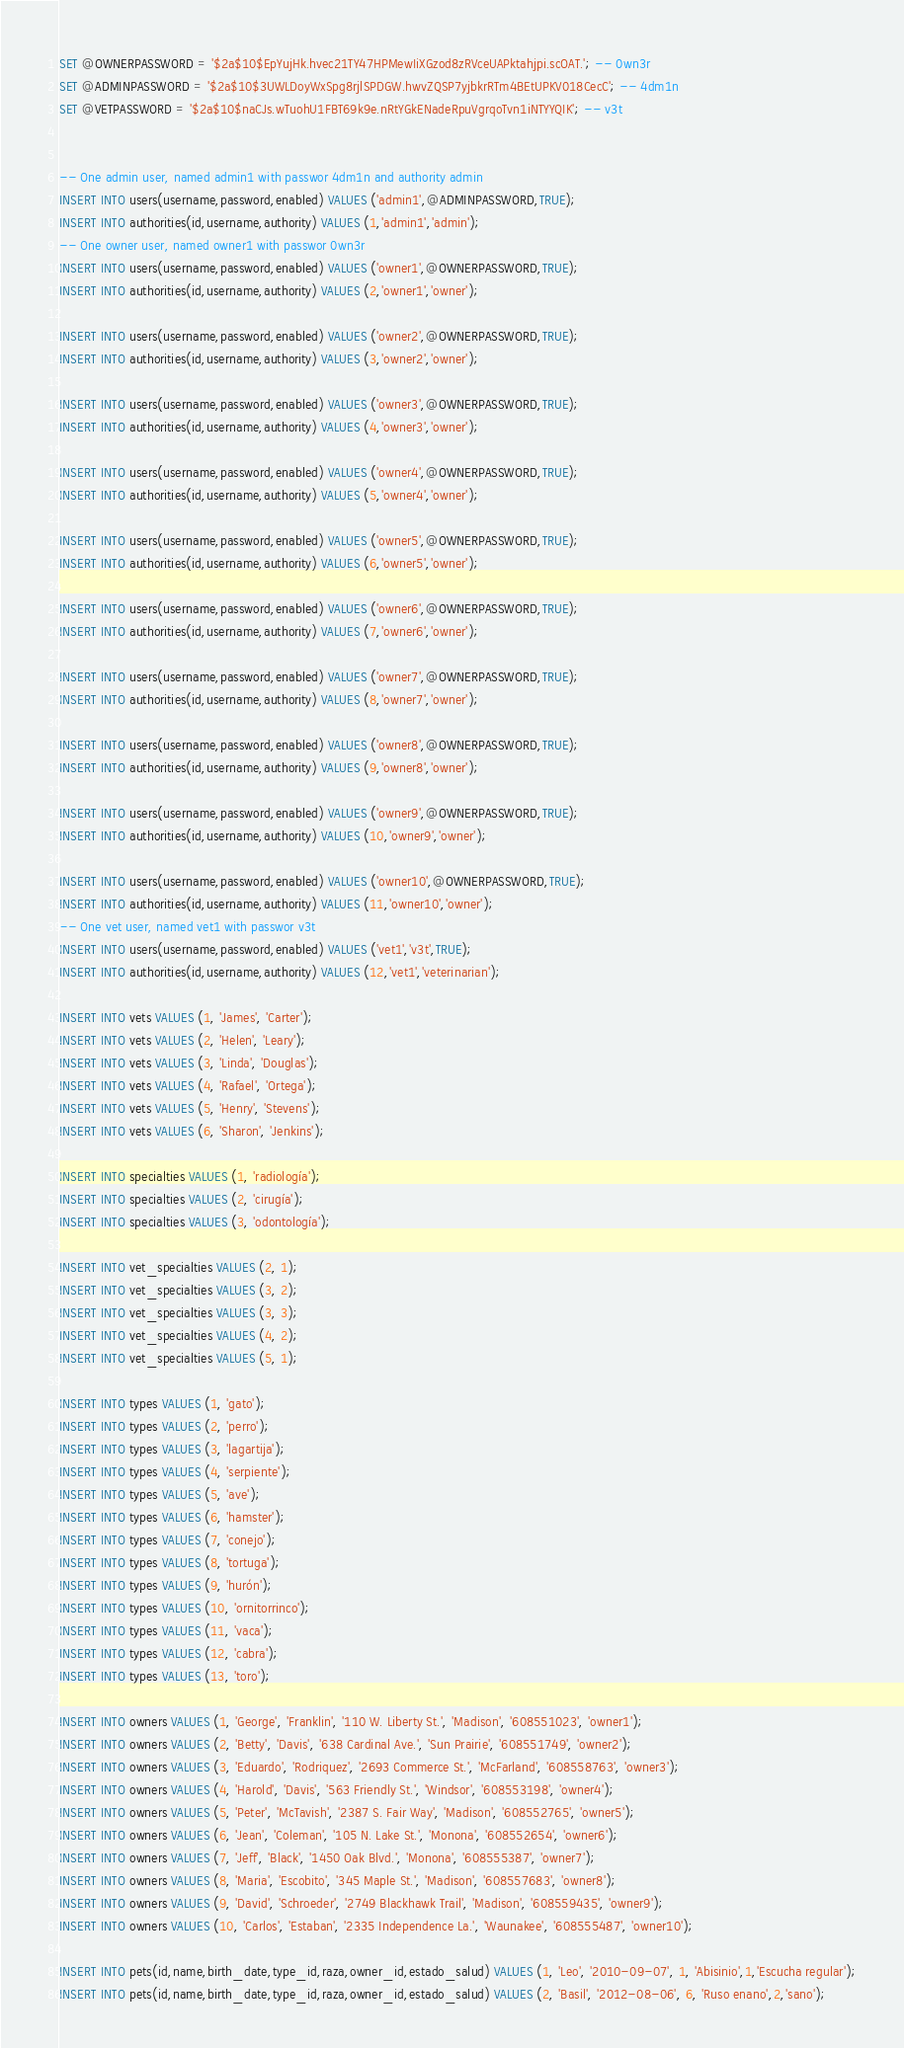Convert code to text. <code><loc_0><loc_0><loc_500><loc_500><_SQL_>SET @OWNERPASSWORD = '$2a$10$EpYujHk.hvec21TY47HPMewIiXGzod8zRVceUAPktahjpi.scOAT.'; -- 0wn3r
SET @ADMINPASSWORD = '$2a$10$3UWLDoyWxSpg8rjlSPDGW.hwvZQSP7yjbkrRTm4BEtUPKV018CecC'; -- 4dm1n
SET @VETPASSWORD = '$2a$10$naCJs.wTuohU1FBT69k9e.nRtYGkENadeRpuVgrqoTvn1iNTYYQIK'; -- v3t


-- One admin user, named admin1 with passwor 4dm1n and authority admin
INSERT INTO users(username,password,enabled) VALUES ('admin1',@ADMINPASSWORD,TRUE);
INSERT INTO authorities(id,username,authority) VALUES (1,'admin1','admin');
-- One owner user, named owner1 with passwor 0wn3r
INSERT INTO users(username,password,enabled) VALUES ('owner1',@OWNERPASSWORD,TRUE);
INSERT INTO authorities(id,username,authority) VALUES (2,'owner1','owner');

INSERT INTO users(username,password,enabled) VALUES ('owner2',@OWNERPASSWORD,TRUE);
INSERT INTO authorities(id,username,authority) VALUES (3,'owner2','owner');

INSERT INTO users(username,password,enabled) VALUES ('owner3',@OWNERPASSWORD,TRUE);
INSERT INTO authorities(id,username,authority) VALUES (4,'owner3','owner');

INSERT INTO users(username,password,enabled) VALUES ('owner4',@OWNERPASSWORD,TRUE);
INSERT INTO authorities(id,username,authority) VALUES (5,'owner4','owner');

INSERT INTO users(username,password,enabled) VALUES ('owner5',@OWNERPASSWORD,TRUE);
INSERT INTO authorities(id,username,authority) VALUES (6,'owner5','owner');

INSERT INTO users(username,password,enabled) VALUES ('owner6',@OWNERPASSWORD,TRUE);
INSERT INTO authorities(id,username,authority) VALUES (7,'owner6','owner');

INSERT INTO users(username,password,enabled) VALUES ('owner7',@OWNERPASSWORD,TRUE);
INSERT INTO authorities(id,username,authority) VALUES (8,'owner7','owner');

INSERT INTO users(username,password,enabled) VALUES ('owner8',@OWNERPASSWORD,TRUE);
INSERT INTO authorities(id,username,authority) VALUES (9,'owner8','owner');

INSERT INTO users(username,password,enabled) VALUES ('owner9',@OWNERPASSWORD,TRUE);
INSERT INTO authorities(id,username,authority) VALUES (10,'owner9','owner');

INSERT INTO users(username,password,enabled) VALUES ('owner10',@OWNERPASSWORD,TRUE);
INSERT INTO authorities(id,username,authority) VALUES (11,'owner10','owner');
-- One vet user, named vet1 with passwor v3t
INSERT INTO users(username,password,enabled) VALUES ('vet1','v3t',TRUE);
INSERT INTO authorities(id,username,authority) VALUES (12,'vet1','veterinarian');

INSERT INTO vets VALUES (1, 'James', 'Carter');
INSERT INTO vets VALUES (2, 'Helen', 'Leary');
INSERT INTO vets VALUES (3, 'Linda', 'Douglas');
INSERT INTO vets VALUES (4, 'Rafael', 'Ortega');
INSERT INTO vets VALUES (5, 'Henry', 'Stevens');
INSERT INTO vets VALUES (6, 'Sharon', 'Jenkins');

INSERT INTO specialties VALUES (1, 'radiología');
INSERT INTO specialties VALUES (2, 'cirugía');
INSERT INTO specialties VALUES (3, 'odontología');

INSERT INTO vet_specialties VALUES (2, 1);
INSERT INTO vet_specialties VALUES (3, 2);
INSERT INTO vet_specialties VALUES (3, 3);
INSERT INTO vet_specialties VALUES (4, 2);
INSERT INTO vet_specialties VALUES (5, 1);

INSERT INTO types VALUES (1, 'gato');
INSERT INTO types VALUES (2, 'perro');
INSERT INTO types VALUES (3, 'lagartija');
INSERT INTO types VALUES (4, 'serpiente');
INSERT INTO types VALUES (5, 'ave');
INSERT INTO types VALUES (6, 'hamster');
INSERT INTO types VALUES (7, 'conejo');
INSERT INTO types VALUES (8, 'tortuga');
INSERT INTO types VALUES (9, 'hurón');
INSERT INTO types VALUES (10, 'ornitorrinco');
INSERT INTO types VALUES (11, 'vaca');
INSERT INTO types VALUES (12, 'cabra');
INSERT INTO types VALUES (13, 'toro');

INSERT INTO owners VALUES (1, 'George', 'Franklin', '110 W. Liberty St.', 'Madison', '608551023', 'owner1');
INSERT INTO owners VALUES (2, 'Betty', 'Davis', '638 Cardinal Ave.', 'Sun Prairie', '608551749', 'owner2');
INSERT INTO owners VALUES (3, 'Eduardo', 'Rodriquez', '2693 Commerce St.', 'McFarland', '608558763', 'owner3');
INSERT INTO owners VALUES (4, 'Harold', 'Davis', '563 Friendly St.', 'Windsor', '608553198', 'owner4');
INSERT INTO owners VALUES (5, 'Peter', 'McTavish', '2387 S. Fair Way', 'Madison', '608552765', 'owner5');
INSERT INTO owners VALUES (6, 'Jean', 'Coleman', '105 N. Lake St.', 'Monona', '608552654', 'owner6');
INSERT INTO owners VALUES (7, 'Jeff', 'Black', '1450 Oak Blvd.', 'Monona', '608555387', 'owner7');
INSERT INTO owners VALUES (8, 'Maria', 'Escobito', '345 Maple St.', 'Madison', '608557683', 'owner8');
INSERT INTO owners VALUES (9, 'David', 'Schroeder', '2749 Blackhawk Trail', 'Madison', '608559435', 'owner9');
INSERT INTO owners VALUES (10, 'Carlos', 'Estaban', '2335 Independence La.', 'Waunakee', '608555487', 'owner10');

INSERT INTO pets(id,name,birth_date,type_id,raza,owner_id,estado_salud) VALUES (1, 'Leo', '2010-09-07', 1, 'Abisinio',1,'Escucha regular');
INSERT INTO pets(id,name,birth_date,type_id,raza,owner_id,estado_salud) VALUES (2, 'Basil', '2012-08-06', 6, 'Ruso enano',2,'sano');</code> 